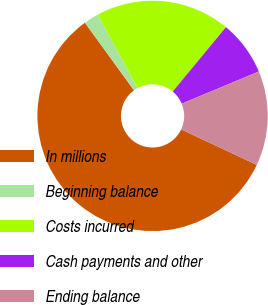Convert chart to OTSL. <chart><loc_0><loc_0><loc_500><loc_500><pie_chart><fcel>In millions<fcel>Beginning balance<fcel>Costs incurred<fcel>Cash payments and other<fcel>Ending balance<nl><fcel>58.01%<fcel>2.11%<fcel>18.88%<fcel>7.7%<fcel>13.29%<nl></chart> 